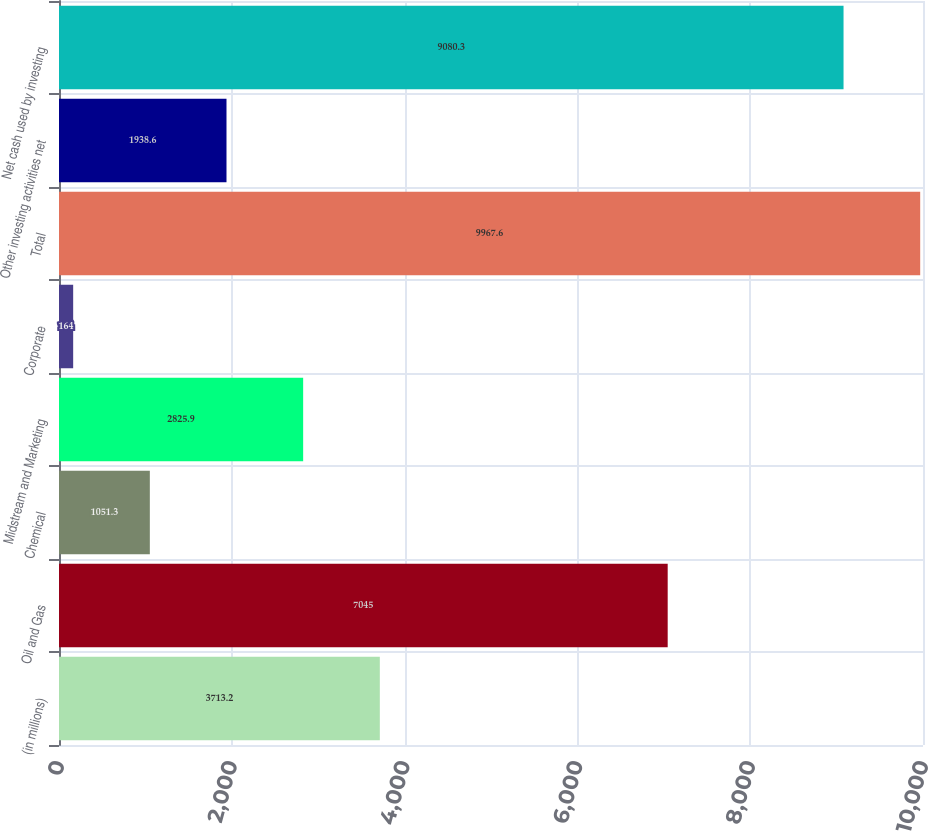<chart> <loc_0><loc_0><loc_500><loc_500><bar_chart><fcel>(in millions)<fcel>Oil and Gas<fcel>Chemical<fcel>Midstream and Marketing<fcel>Corporate<fcel>Total<fcel>Other investing activities net<fcel>Net cash used by investing<nl><fcel>3713.2<fcel>7045<fcel>1051.3<fcel>2825.9<fcel>164<fcel>9967.6<fcel>1938.6<fcel>9080.3<nl></chart> 